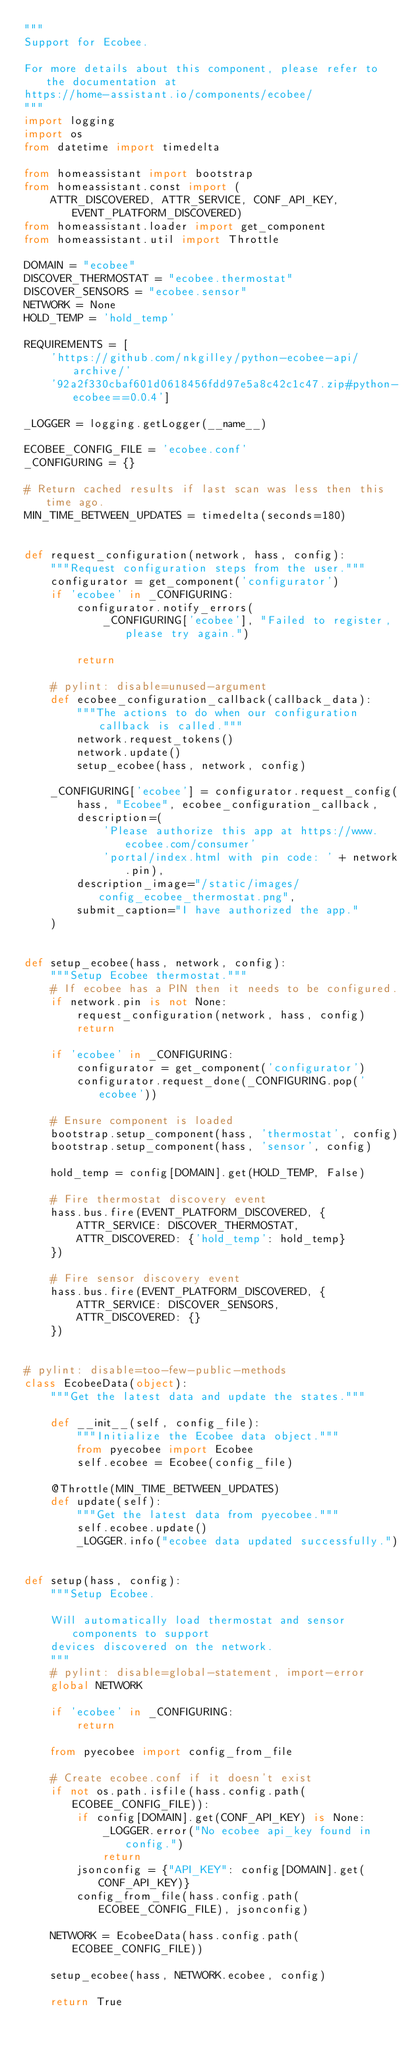Convert code to text. <code><loc_0><loc_0><loc_500><loc_500><_Python_>"""
Support for Ecobee.

For more details about this component, please refer to the documentation at
https://home-assistant.io/components/ecobee/
"""
import logging
import os
from datetime import timedelta

from homeassistant import bootstrap
from homeassistant.const import (
    ATTR_DISCOVERED, ATTR_SERVICE, CONF_API_KEY, EVENT_PLATFORM_DISCOVERED)
from homeassistant.loader import get_component
from homeassistant.util import Throttle

DOMAIN = "ecobee"
DISCOVER_THERMOSTAT = "ecobee.thermostat"
DISCOVER_SENSORS = "ecobee.sensor"
NETWORK = None
HOLD_TEMP = 'hold_temp'

REQUIREMENTS = [
    'https://github.com/nkgilley/python-ecobee-api/archive/'
    '92a2f330cbaf601d0618456fdd97e5a8c42c1c47.zip#python-ecobee==0.0.4']

_LOGGER = logging.getLogger(__name__)

ECOBEE_CONFIG_FILE = 'ecobee.conf'
_CONFIGURING = {}

# Return cached results if last scan was less then this time ago.
MIN_TIME_BETWEEN_UPDATES = timedelta(seconds=180)


def request_configuration(network, hass, config):
    """Request configuration steps from the user."""
    configurator = get_component('configurator')
    if 'ecobee' in _CONFIGURING:
        configurator.notify_errors(
            _CONFIGURING['ecobee'], "Failed to register, please try again.")

        return

    # pylint: disable=unused-argument
    def ecobee_configuration_callback(callback_data):
        """The actions to do when our configuration callback is called."""
        network.request_tokens()
        network.update()
        setup_ecobee(hass, network, config)

    _CONFIGURING['ecobee'] = configurator.request_config(
        hass, "Ecobee", ecobee_configuration_callback,
        description=(
            'Please authorize this app at https://www.ecobee.com/consumer'
            'portal/index.html with pin code: ' + network.pin),
        description_image="/static/images/config_ecobee_thermostat.png",
        submit_caption="I have authorized the app."
    )


def setup_ecobee(hass, network, config):
    """Setup Ecobee thermostat."""
    # If ecobee has a PIN then it needs to be configured.
    if network.pin is not None:
        request_configuration(network, hass, config)
        return

    if 'ecobee' in _CONFIGURING:
        configurator = get_component('configurator')
        configurator.request_done(_CONFIGURING.pop('ecobee'))

    # Ensure component is loaded
    bootstrap.setup_component(hass, 'thermostat', config)
    bootstrap.setup_component(hass, 'sensor', config)

    hold_temp = config[DOMAIN].get(HOLD_TEMP, False)

    # Fire thermostat discovery event
    hass.bus.fire(EVENT_PLATFORM_DISCOVERED, {
        ATTR_SERVICE: DISCOVER_THERMOSTAT,
        ATTR_DISCOVERED: {'hold_temp': hold_temp}
    })

    # Fire sensor discovery event
    hass.bus.fire(EVENT_PLATFORM_DISCOVERED, {
        ATTR_SERVICE: DISCOVER_SENSORS,
        ATTR_DISCOVERED: {}
    })


# pylint: disable=too-few-public-methods
class EcobeeData(object):
    """Get the latest data and update the states."""

    def __init__(self, config_file):
        """Initialize the Ecobee data object."""
        from pyecobee import Ecobee
        self.ecobee = Ecobee(config_file)

    @Throttle(MIN_TIME_BETWEEN_UPDATES)
    def update(self):
        """Get the latest data from pyecobee."""
        self.ecobee.update()
        _LOGGER.info("ecobee data updated successfully.")


def setup(hass, config):
    """Setup Ecobee.

    Will automatically load thermostat and sensor components to support
    devices discovered on the network.
    """
    # pylint: disable=global-statement, import-error
    global NETWORK

    if 'ecobee' in _CONFIGURING:
        return

    from pyecobee import config_from_file

    # Create ecobee.conf if it doesn't exist
    if not os.path.isfile(hass.config.path(ECOBEE_CONFIG_FILE)):
        if config[DOMAIN].get(CONF_API_KEY) is None:
            _LOGGER.error("No ecobee api_key found in config.")
            return
        jsonconfig = {"API_KEY": config[DOMAIN].get(CONF_API_KEY)}
        config_from_file(hass.config.path(ECOBEE_CONFIG_FILE), jsonconfig)

    NETWORK = EcobeeData(hass.config.path(ECOBEE_CONFIG_FILE))

    setup_ecobee(hass, NETWORK.ecobee, config)

    return True
</code> 